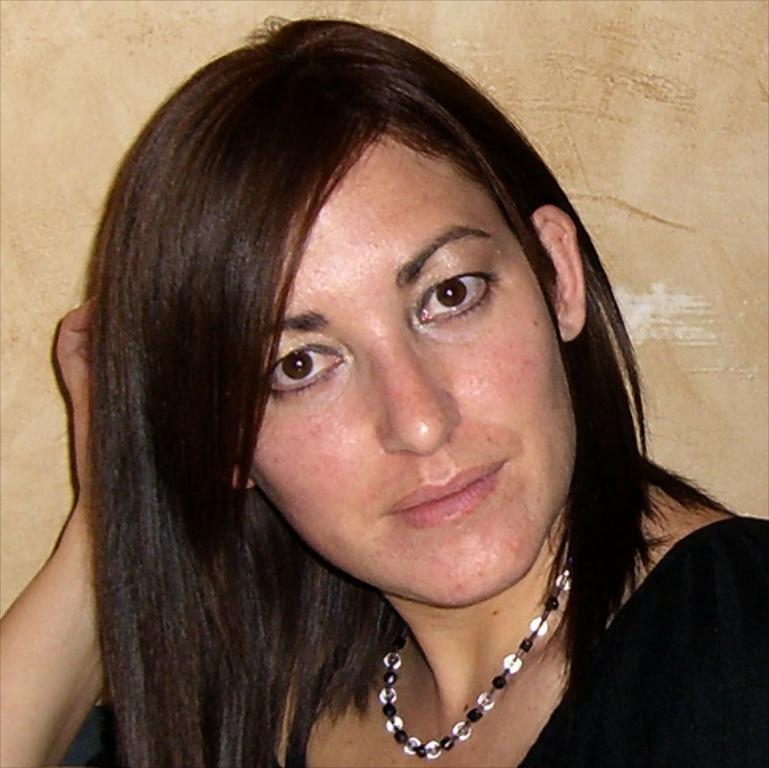Describe this image in one or two sentences. In this image we can see a woman. She is wearing a pearl necklace and black dress. 